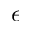Convert formula to latex. <formula><loc_0><loc_0><loc_500><loc_500>\epsilon</formula> 